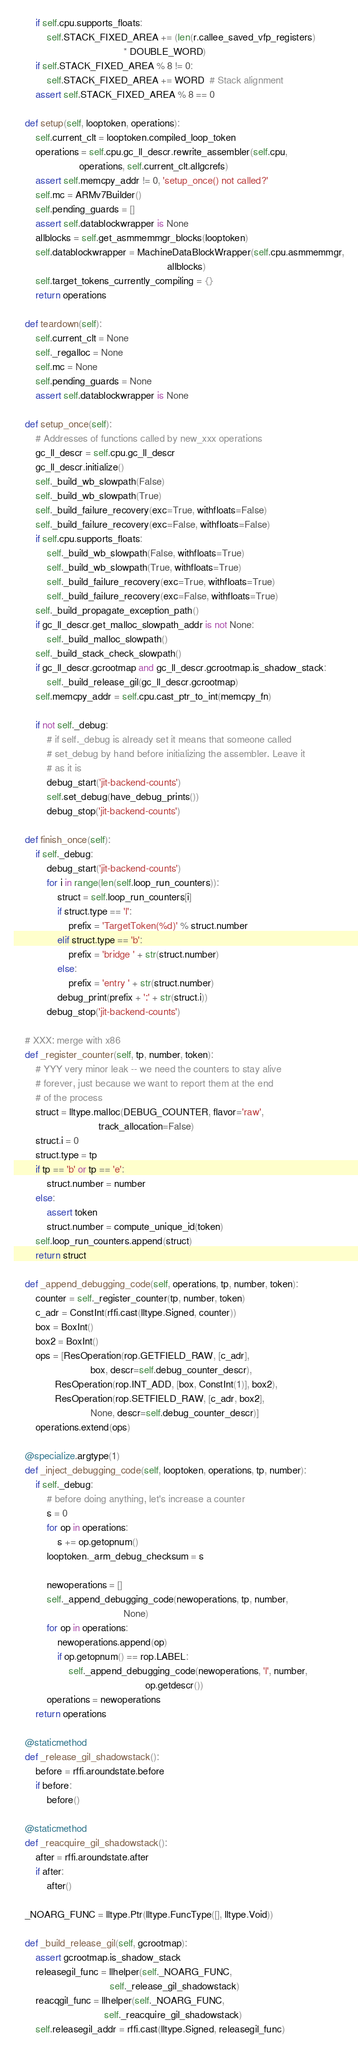Convert code to text. <code><loc_0><loc_0><loc_500><loc_500><_Python_>        if self.cpu.supports_floats:
            self.STACK_FIXED_AREA += (len(r.callee_saved_vfp_registers)
                                        * DOUBLE_WORD)
        if self.STACK_FIXED_AREA % 8 != 0:
            self.STACK_FIXED_AREA += WORD  # Stack alignment
        assert self.STACK_FIXED_AREA % 8 == 0

    def setup(self, looptoken, operations):
        self.current_clt = looptoken.compiled_loop_token
        operations = self.cpu.gc_ll_descr.rewrite_assembler(self.cpu,
                        operations, self.current_clt.allgcrefs)
        assert self.memcpy_addr != 0, 'setup_once() not called?'
        self.mc = ARMv7Builder()
        self.pending_guards = []
        assert self.datablockwrapper is None
        allblocks = self.get_asmmemmgr_blocks(looptoken)
        self.datablockwrapper = MachineDataBlockWrapper(self.cpu.asmmemmgr,
                                                        allblocks)
        self.target_tokens_currently_compiling = {}
        return operations

    def teardown(self):
        self.current_clt = None
        self._regalloc = None
        self.mc = None
        self.pending_guards = None
        assert self.datablockwrapper is None

    def setup_once(self):
        # Addresses of functions called by new_xxx operations
        gc_ll_descr = self.cpu.gc_ll_descr
        gc_ll_descr.initialize()
        self._build_wb_slowpath(False)
        self._build_wb_slowpath(True)
        self._build_failure_recovery(exc=True, withfloats=False)
        self._build_failure_recovery(exc=False, withfloats=False)
        if self.cpu.supports_floats:
            self._build_wb_slowpath(False, withfloats=True)
            self._build_wb_slowpath(True, withfloats=True)
            self._build_failure_recovery(exc=True, withfloats=True)
            self._build_failure_recovery(exc=False, withfloats=True)
        self._build_propagate_exception_path()
        if gc_ll_descr.get_malloc_slowpath_addr is not None:
            self._build_malloc_slowpath()
        self._build_stack_check_slowpath()
        if gc_ll_descr.gcrootmap and gc_ll_descr.gcrootmap.is_shadow_stack:
            self._build_release_gil(gc_ll_descr.gcrootmap)
        self.memcpy_addr = self.cpu.cast_ptr_to_int(memcpy_fn)

        if not self._debug:
            # if self._debug is already set it means that someone called
            # set_debug by hand before initializing the assembler. Leave it
            # as it is
            debug_start('jit-backend-counts')
            self.set_debug(have_debug_prints())
            debug_stop('jit-backend-counts')

    def finish_once(self):
        if self._debug:
            debug_start('jit-backend-counts')
            for i in range(len(self.loop_run_counters)):
                struct = self.loop_run_counters[i]
                if struct.type == 'l':
                    prefix = 'TargetToken(%d)' % struct.number
                elif struct.type == 'b':
                    prefix = 'bridge ' + str(struct.number)
                else:
                    prefix = 'entry ' + str(struct.number)
                debug_print(prefix + ':' + str(struct.i))
            debug_stop('jit-backend-counts')

    # XXX: merge with x86
    def _register_counter(self, tp, number, token):
        # YYY very minor leak -- we need the counters to stay alive
        # forever, just because we want to report them at the end
        # of the process
        struct = lltype.malloc(DEBUG_COUNTER, flavor='raw',
                               track_allocation=False)
        struct.i = 0
        struct.type = tp
        if tp == 'b' or tp == 'e':
            struct.number = number
        else:
            assert token
            struct.number = compute_unique_id(token)
        self.loop_run_counters.append(struct)
        return struct

    def _append_debugging_code(self, operations, tp, number, token):
        counter = self._register_counter(tp, number, token)
        c_adr = ConstInt(rffi.cast(lltype.Signed, counter))
        box = BoxInt()
        box2 = BoxInt()
        ops = [ResOperation(rop.GETFIELD_RAW, [c_adr],
                            box, descr=self.debug_counter_descr),
               ResOperation(rop.INT_ADD, [box, ConstInt(1)], box2),
               ResOperation(rop.SETFIELD_RAW, [c_adr, box2],
                            None, descr=self.debug_counter_descr)]
        operations.extend(ops)

    @specialize.argtype(1)
    def _inject_debugging_code(self, looptoken, operations, tp, number):
        if self._debug:
            # before doing anything, let's increase a counter
            s = 0
            for op in operations:
                s += op.getopnum()
            looptoken._arm_debug_checksum = s

            newoperations = []
            self._append_debugging_code(newoperations, tp, number,
                                        None)
            for op in operations:
                newoperations.append(op)
                if op.getopnum() == rop.LABEL:
                    self._append_debugging_code(newoperations, 'l', number,
                                                op.getdescr())
            operations = newoperations
        return operations

    @staticmethod
    def _release_gil_shadowstack():
        before = rffi.aroundstate.before
        if before:
            before()

    @staticmethod
    def _reacquire_gil_shadowstack():
        after = rffi.aroundstate.after
        if after:
            after()

    _NOARG_FUNC = lltype.Ptr(lltype.FuncType([], lltype.Void))

    def _build_release_gil(self, gcrootmap):
        assert gcrootmap.is_shadow_stack
        releasegil_func = llhelper(self._NOARG_FUNC,
                                   self._release_gil_shadowstack)
        reacqgil_func = llhelper(self._NOARG_FUNC,
                                 self._reacquire_gil_shadowstack)
        self.releasegil_addr = rffi.cast(lltype.Signed, releasegil_func)</code> 